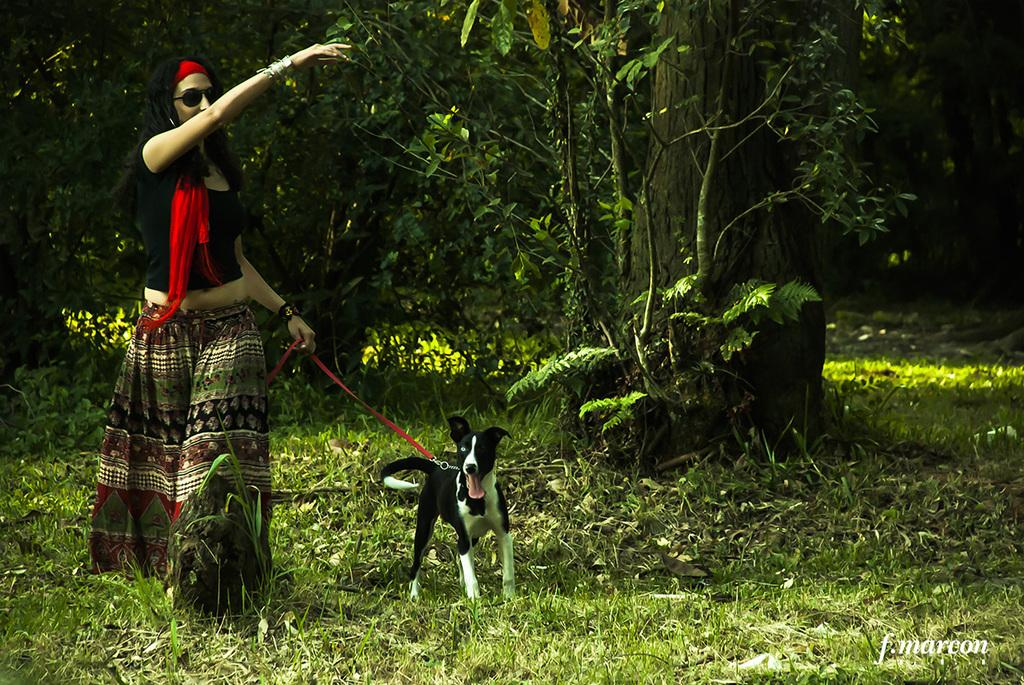Who is the main subject in the image? There is a woman in the image. What is the woman doing in the image? The woman is walking in the image. What is the woman holding in the image? The woman is holding a dog in the image. What can be seen in the foreground of the image? There are plants and grass in the foreground of the image. What can be seen in the background of the image? There are trees in the background of the image. What type of cheese is being used to create a spark in the image? There is no cheese or spark present in the image. How does the water affect the woman's walk in the image? There is no water present in the image, so it does not affect the woman's walk. 